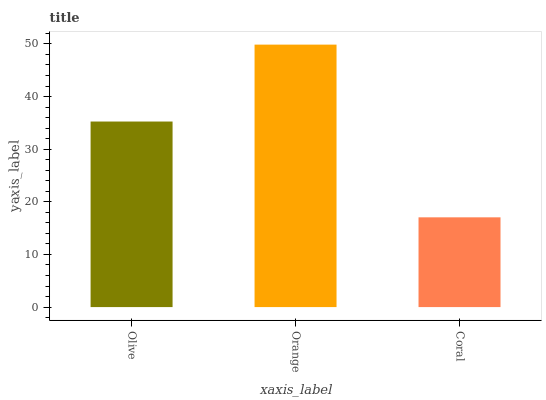Is Coral the minimum?
Answer yes or no. Yes. Is Orange the maximum?
Answer yes or no. Yes. Is Orange the minimum?
Answer yes or no. No. Is Coral the maximum?
Answer yes or no. No. Is Orange greater than Coral?
Answer yes or no. Yes. Is Coral less than Orange?
Answer yes or no. Yes. Is Coral greater than Orange?
Answer yes or no. No. Is Orange less than Coral?
Answer yes or no. No. Is Olive the high median?
Answer yes or no. Yes. Is Olive the low median?
Answer yes or no. Yes. Is Orange the high median?
Answer yes or no. No. Is Coral the low median?
Answer yes or no. No. 